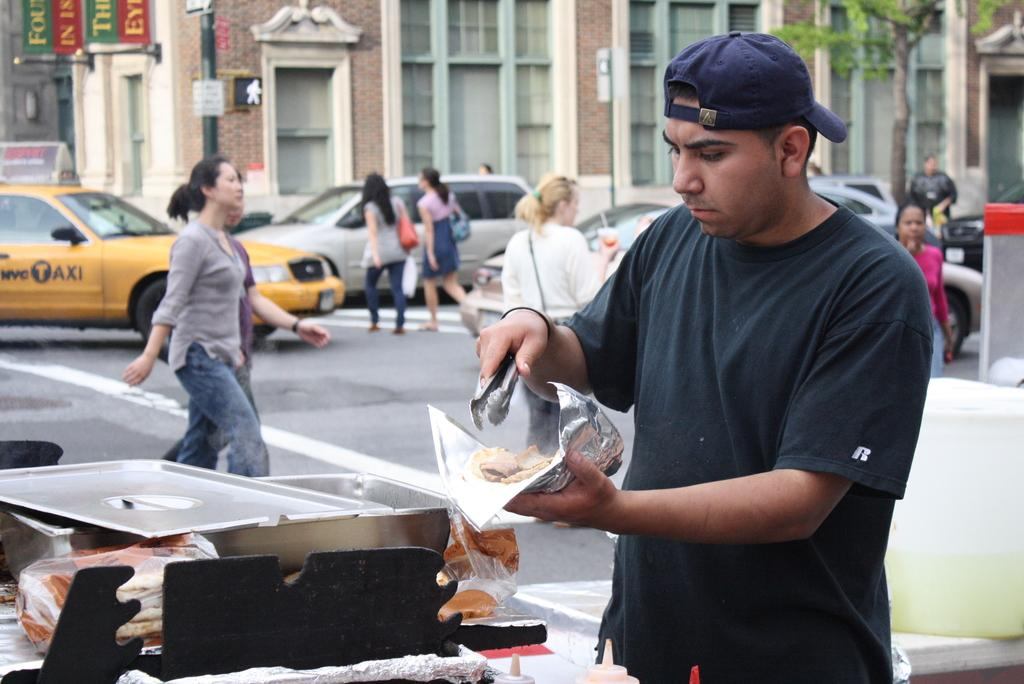<image>
Create a compact narrative representing the image presented. A yellow NYC Taxi can be seen in the background behind the girl walking. 